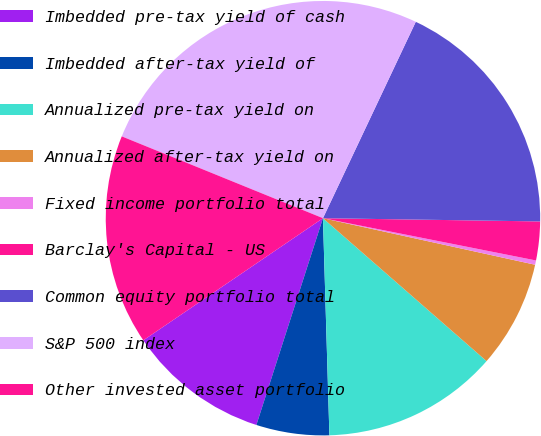<chart> <loc_0><loc_0><loc_500><loc_500><pie_chart><fcel>Imbedded pre-tax yield of cash<fcel>Imbedded after-tax yield of<fcel>Annualized pre-tax yield on<fcel>Annualized after-tax yield on<fcel>Fixed income portfolio total<fcel>Barclay's Capital - US<fcel>Common equity portfolio total<fcel>S&P 500 index<fcel>Other invested asset portfolio<nl><fcel>10.54%<fcel>5.43%<fcel>13.1%<fcel>7.99%<fcel>0.32%<fcel>2.88%<fcel>18.21%<fcel>25.88%<fcel>15.65%<nl></chart> 